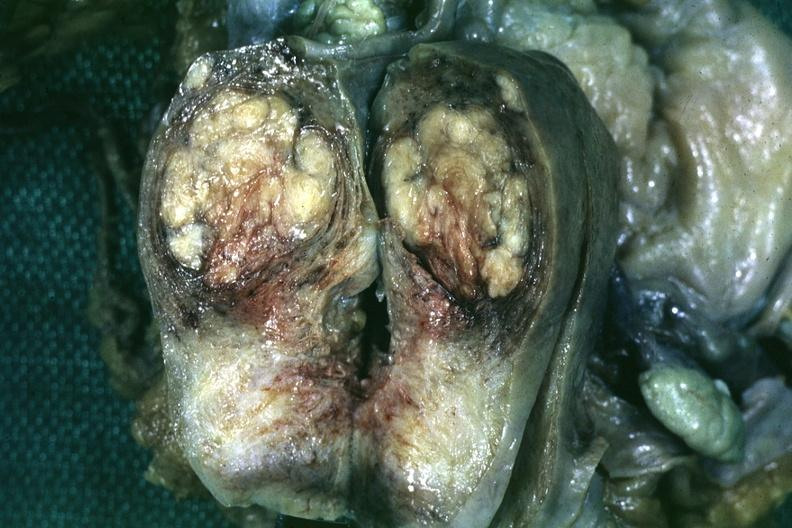s this section present?
Answer the question using a single word or phrase. No 